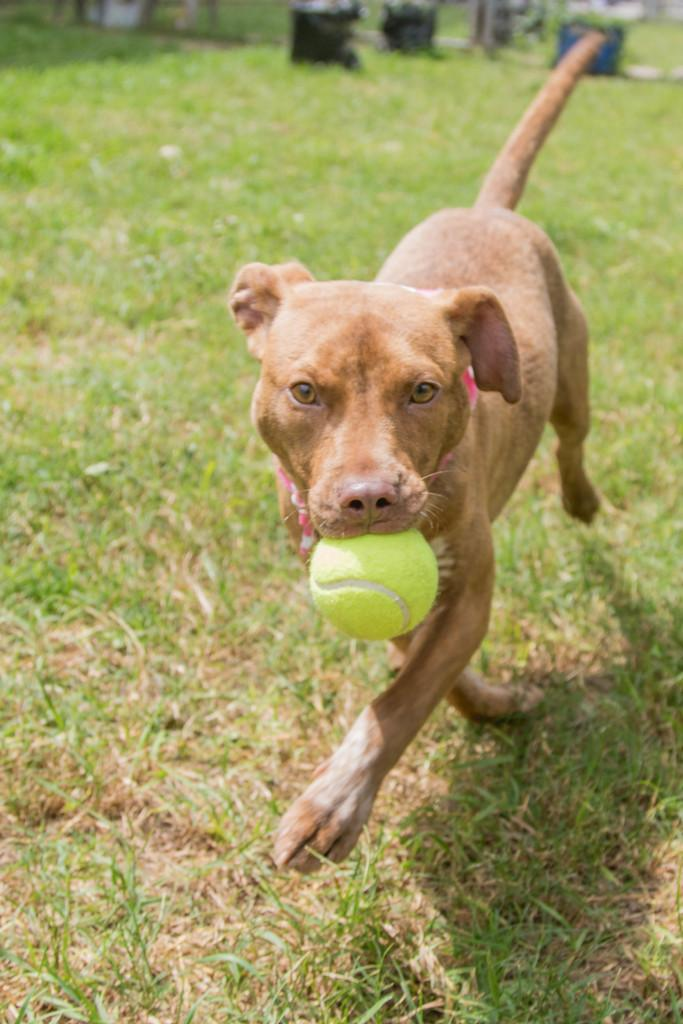What animal is present in the image? There is a dog in the image. What is the dog holding in its mouth? The dog has a ball in its mouth. What type of surface is visible in the image? There is ground visible in the image. What can be found on the ground in the image? There are objects on the ground. What type of vegetation is present in the image? There is grass in the image. What color can be observed among the objects in the image? There are black colored objects in the image. What reason does the dog have for standing on the shelf in the image? There is no shelf present in the image, and the dog is not standing on one. 